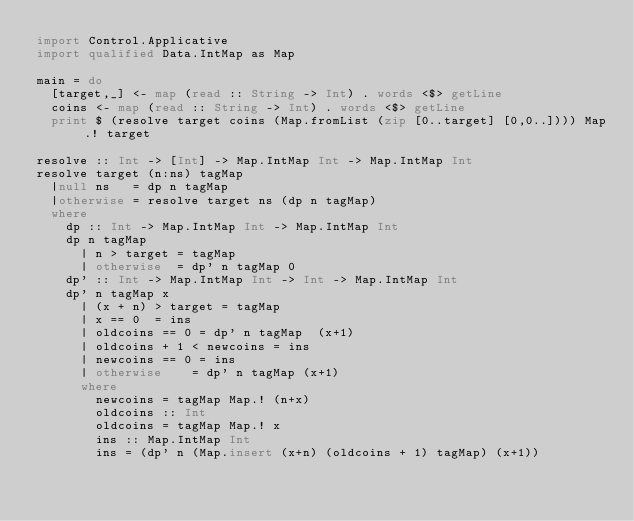Convert code to text. <code><loc_0><loc_0><loc_500><loc_500><_Haskell_>import Control.Applicative
import qualified Data.IntMap as Map

main = do
  [target,_] <- map (read :: String -> Int) . words <$> getLine
  coins <- map (read :: String -> Int) . words <$> getLine
  print $ (resolve target coins (Map.fromList (zip [0..target] [0,0..]))) Map.! target

resolve :: Int -> [Int] -> Map.IntMap Int -> Map.IntMap Int
resolve target (n:ns) tagMap
  |null ns   = dp n tagMap
  |otherwise = resolve target ns (dp n tagMap)
  where
    dp :: Int -> Map.IntMap Int -> Map.IntMap Int
    dp n tagMap
      | n > target = tagMap
      | otherwise  = dp' n tagMap 0
    dp' :: Int -> Map.IntMap Int -> Int -> Map.IntMap Int
    dp' n tagMap x
      | (x + n) > target = tagMap
      | x == 0  = ins
      | oldcoins == 0 = dp' n tagMap  (x+1)
      | oldcoins + 1 < newcoins = ins
      | newcoins == 0 = ins
      | otherwise    = dp' n tagMap (x+1)
      where
        newcoins = tagMap Map.! (n+x)
        oldcoins :: Int
        oldcoins = tagMap Map.! x
        ins :: Map.IntMap Int
        ins = (dp' n (Map.insert (x+n) (oldcoins + 1) tagMap) (x+1))</code> 